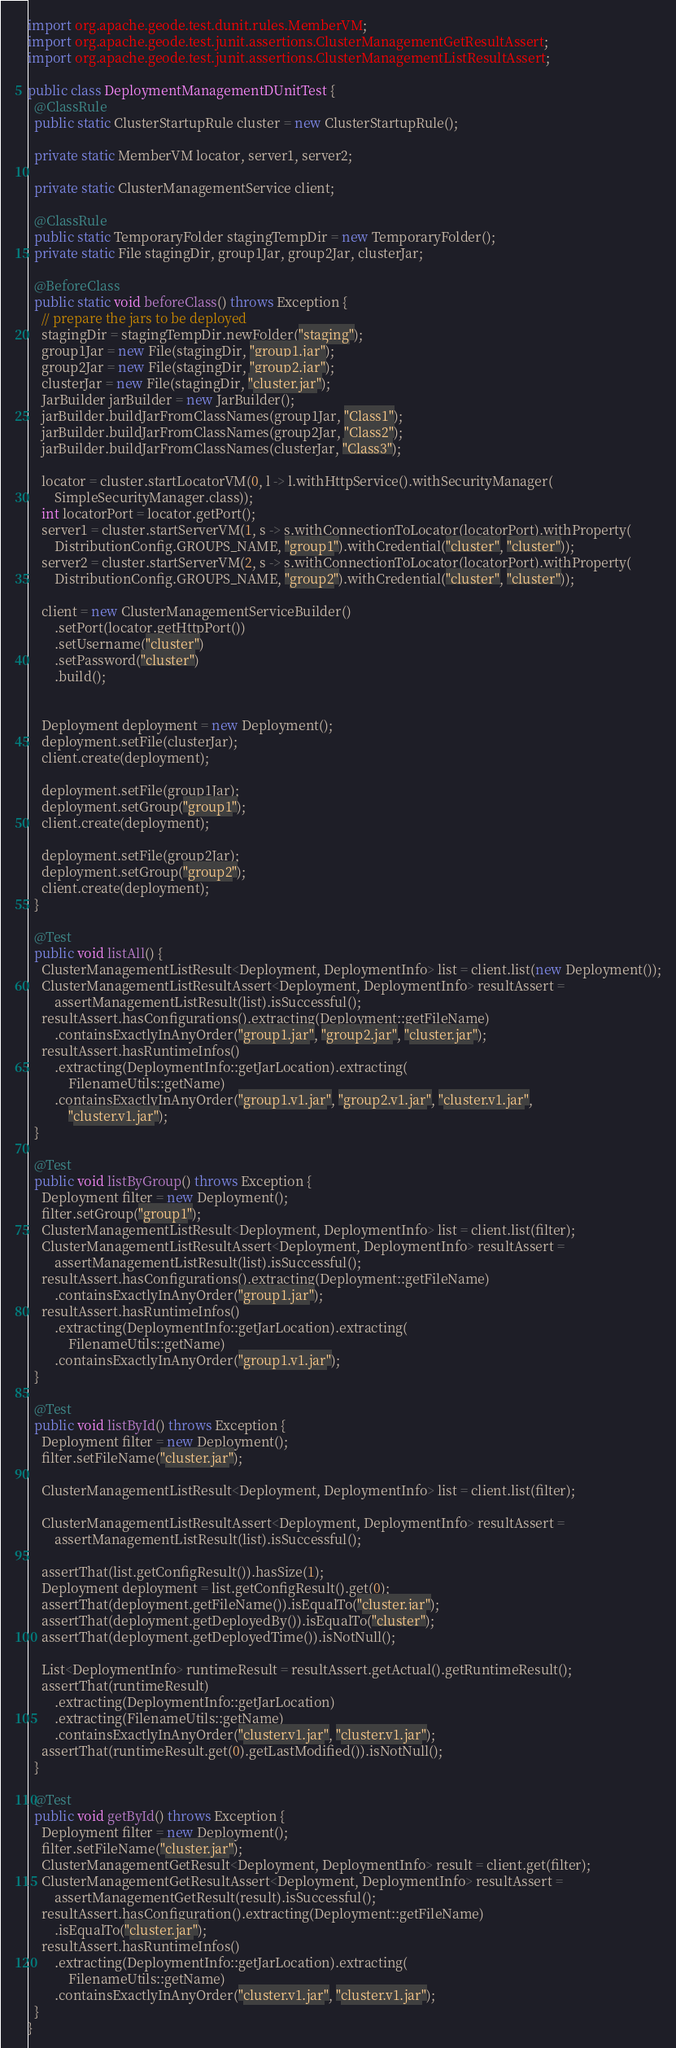Convert code to text. <code><loc_0><loc_0><loc_500><loc_500><_Java_>import org.apache.geode.test.dunit.rules.MemberVM;
import org.apache.geode.test.junit.assertions.ClusterManagementGetResultAssert;
import org.apache.geode.test.junit.assertions.ClusterManagementListResultAssert;

public class DeploymentManagementDUnitTest {
  @ClassRule
  public static ClusterStartupRule cluster = new ClusterStartupRule();

  private static MemberVM locator, server1, server2;

  private static ClusterManagementService client;

  @ClassRule
  public static TemporaryFolder stagingTempDir = new TemporaryFolder();
  private static File stagingDir, group1Jar, group2Jar, clusterJar;

  @BeforeClass
  public static void beforeClass() throws Exception {
    // prepare the jars to be deployed
    stagingDir = stagingTempDir.newFolder("staging");
    group1Jar = new File(stagingDir, "group1.jar");
    group2Jar = new File(stagingDir, "group2.jar");
    clusterJar = new File(stagingDir, "cluster.jar");
    JarBuilder jarBuilder = new JarBuilder();
    jarBuilder.buildJarFromClassNames(group1Jar, "Class1");
    jarBuilder.buildJarFromClassNames(group2Jar, "Class2");
    jarBuilder.buildJarFromClassNames(clusterJar, "Class3");

    locator = cluster.startLocatorVM(0, l -> l.withHttpService().withSecurityManager(
        SimpleSecurityManager.class));
    int locatorPort = locator.getPort();
    server1 = cluster.startServerVM(1, s -> s.withConnectionToLocator(locatorPort).withProperty(
        DistributionConfig.GROUPS_NAME, "group1").withCredential("cluster", "cluster"));
    server2 = cluster.startServerVM(2, s -> s.withConnectionToLocator(locatorPort).withProperty(
        DistributionConfig.GROUPS_NAME, "group2").withCredential("cluster", "cluster"));

    client = new ClusterManagementServiceBuilder()
        .setPort(locator.getHttpPort())
        .setUsername("cluster")
        .setPassword("cluster")
        .build();


    Deployment deployment = new Deployment();
    deployment.setFile(clusterJar);
    client.create(deployment);

    deployment.setFile(group1Jar);
    deployment.setGroup("group1");
    client.create(deployment);

    deployment.setFile(group2Jar);
    deployment.setGroup("group2");
    client.create(deployment);
  }

  @Test
  public void listAll() {
    ClusterManagementListResult<Deployment, DeploymentInfo> list = client.list(new Deployment());
    ClusterManagementListResultAssert<Deployment, DeploymentInfo> resultAssert =
        assertManagementListResult(list).isSuccessful();
    resultAssert.hasConfigurations().extracting(Deployment::getFileName)
        .containsExactlyInAnyOrder("group1.jar", "group2.jar", "cluster.jar");
    resultAssert.hasRuntimeInfos()
        .extracting(DeploymentInfo::getJarLocation).extracting(
            FilenameUtils::getName)
        .containsExactlyInAnyOrder("group1.v1.jar", "group2.v1.jar", "cluster.v1.jar",
            "cluster.v1.jar");
  }

  @Test
  public void listByGroup() throws Exception {
    Deployment filter = new Deployment();
    filter.setGroup("group1");
    ClusterManagementListResult<Deployment, DeploymentInfo> list = client.list(filter);
    ClusterManagementListResultAssert<Deployment, DeploymentInfo> resultAssert =
        assertManagementListResult(list).isSuccessful();
    resultAssert.hasConfigurations().extracting(Deployment::getFileName)
        .containsExactlyInAnyOrder("group1.jar");
    resultAssert.hasRuntimeInfos()
        .extracting(DeploymentInfo::getJarLocation).extracting(
            FilenameUtils::getName)
        .containsExactlyInAnyOrder("group1.v1.jar");
  }

  @Test
  public void listById() throws Exception {
    Deployment filter = new Deployment();
    filter.setFileName("cluster.jar");

    ClusterManagementListResult<Deployment, DeploymentInfo> list = client.list(filter);

    ClusterManagementListResultAssert<Deployment, DeploymentInfo> resultAssert =
        assertManagementListResult(list).isSuccessful();

    assertThat(list.getConfigResult()).hasSize(1);
    Deployment deployment = list.getConfigResult().get(0);
    assertThat(deployment.getFileName()).isEqualTo("cluster.jar");
    assertThat(deployment.getDeployedBy()).isEqualTo("cluster");
    assertThat(deployment.getDeployedTime()).isNotNull();

    List<DeploymentInfo> runtimeResult = resultAssert.getActual().getRuntimeResult();
    assertThat(runtimeResult)
        .extracting(DeploymentInfo::getJarLocation)
        .extracting(FilenameUtils::getName)
        .containsExactlyInAnyOrder("cluster.v1.jar", "cluster.v1.jar");
    assertThat(runtimeResult.get(0).getLastModified()).isNotNull();
  }

  @Test
  public void getById() throws Exception {
    Deployment filter = new Deployment();
    filter.setFileName("cluster.jar");
    ClusterManagementGetResult<Deployment, DeploymentInfo> result = client.get(filter);
    ClusterManagementGetResultAssert<Deployment, DeploymentInfo> resultAssert =
        assertManagementGetResult(result).isSuccessful();
    resultAssert.hasConfiguration().extracting(Deployment::getFileName)
        .isEqualTo("cluster.jar");
    resultAssert.hasRuntimeInfos()
        .extracting(DeploymentInfo::getJarLocation).extracting(
            FilenameUtils::getName)
        .containsExactlyInAnyOrder("cluster.v1.jar", "cluster.v1.jar");
  }
}
</code> 